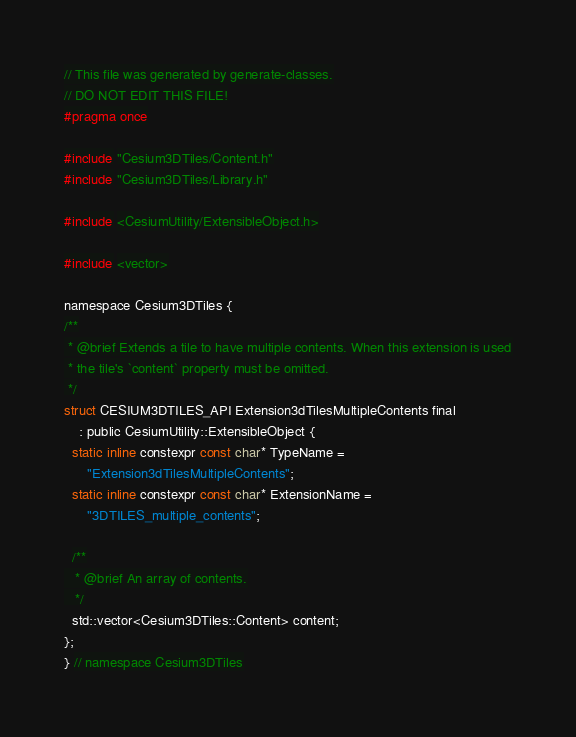Convert code to text. <code><loc_0><loc_0><loc_500><loc_500><_C_>// This file was generated by generate-classes.
// DO NOT EDIT THIS FILE!
#pragma once

#include "Cesium3DTiles/Content.h"
#include "Cesium3DTiles/Library.h"

#include <CesiumUtility/ExtensibleObject.h>

#include <vector>

namespace Cesium3DTiles {
/**
 * @brief Extends a tile to have multiple contents. When this extension is used
 * the tile's `content` property must be omitted.
 */
struct CESIUM3DTILES_API Extension3dTilesMultipleContents final
    : public CesiumUtility::ExtensibleObject {
  static inline constexpr const char* TypeName =
      "Extension3dTilesMultipleContents";
  static inline constexpr const char* ExtensionName =
      "3DTILES_multiple_contents";

  /**
   * @brief An array of contents.
   */
  std::vector<Cesium3DTiles::Content> content;
};
} // namespace Cesium3DTiles
</code> 